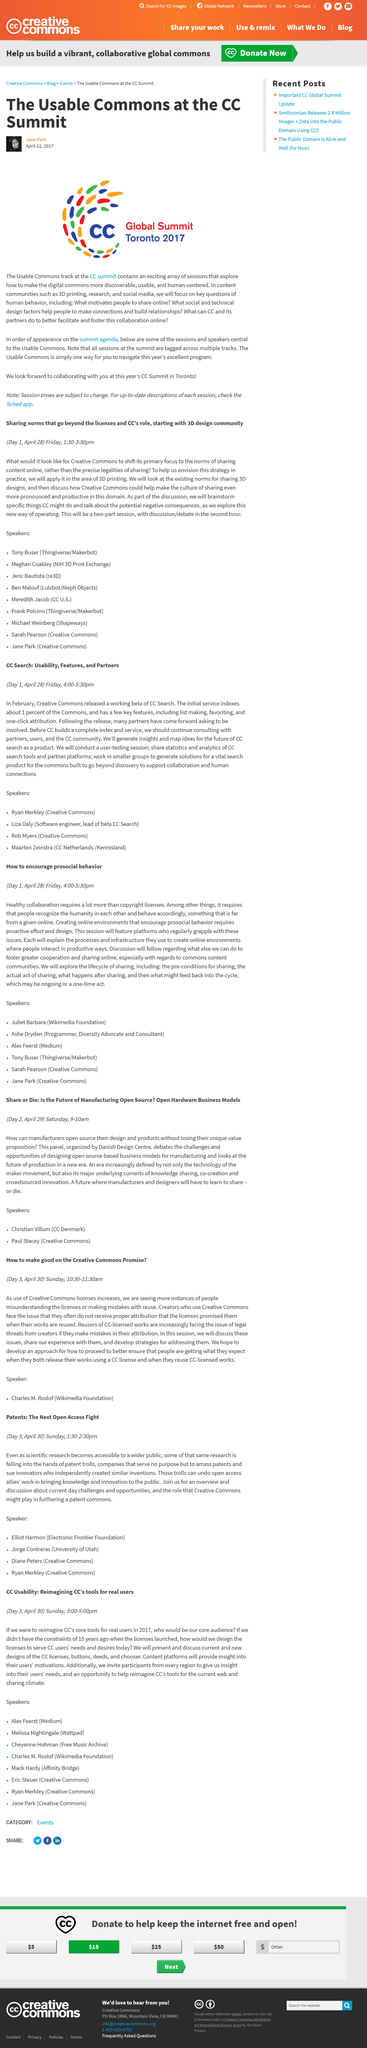List a handful of essential elements in this visual. The usable commons track will be present at the CC Summit. The Usable Commons Track will feature sessions that focus on enhancing the accessibility and user-friendliness of digital commons in order to better serve human needs and interests. There are several content communities available, including 3D printing, research, and social media. 